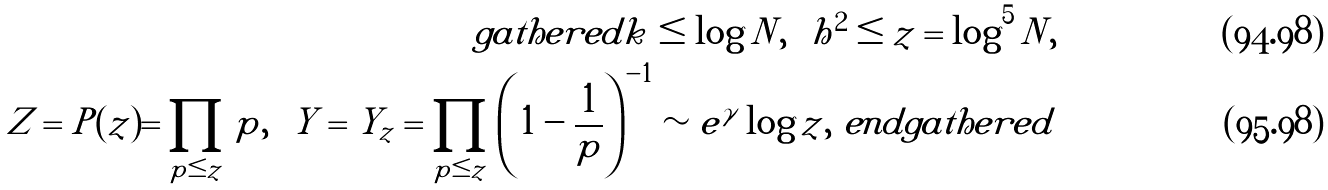<formula> <loc_0><loc_0><loc_500><loc_500>\ g a t h e r e d k \leq \log N , \ \ h ^ { 2 } \leq z = \log ^ { 5 } N , \\ Z = P ( z ) = \prod _ { p \leq z } p , \ \ Y = Y _ { z } = \prod _ { p \leq z } \left ( 1 - \frac { 1 } { p } \right ) ^ { - 1 } \sim e ^ { \gamma } \log z , \ e n d g a t h e r e d</formula> 